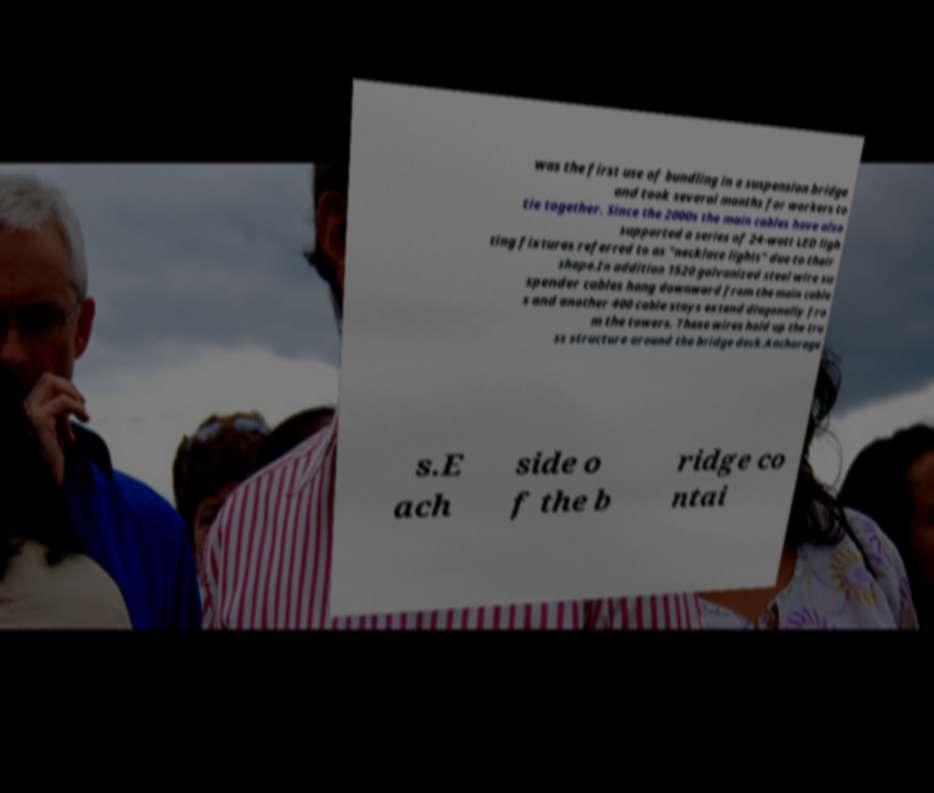There's text embedded in this image that I need extracted. Can you transcribe it verbatim? was the first use of bundling in a suspension bridge and took several months for workers to tie together. Since the 2000s the main cables have also supported a series of 24-watt LED ligh ting fixtures referred to as "necklace lights" due to their shape.In addition 1520 galvanized steel wire su spender cables hang downward from the main cable s and another 400 cable stays extend diagonally fro m the towers. These wires hold up the tru ss structure around the bridge deck.Anchorage s.E ach side o f the b ridge co ntai 